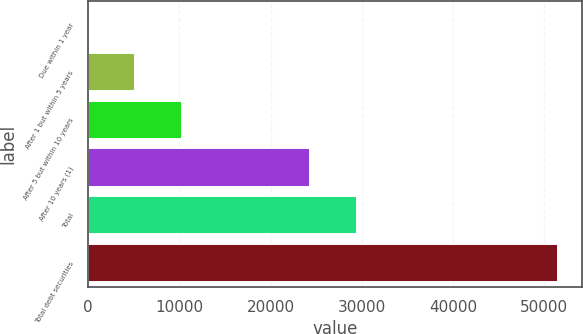<chart> <loc_0><loc_0><loc_500><loc_500><bar_chart><fcel>Due within 1 year<fcel>After 1 but within 5 years<fcel>After 5 but within 10 years<fcel>After 10 years (1)<fcel>Total<fcel>Total debt securities<nl><fcel>1<fcel>5153.6<fcel>10306.2<fcel>24337<fcel>29489.6<fcel>51527<nl></chart> 